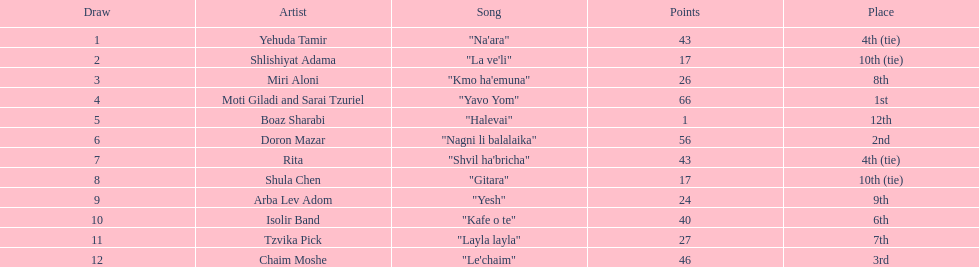What is the title of the track that precedes "yesh" in the list? "Gitara". 